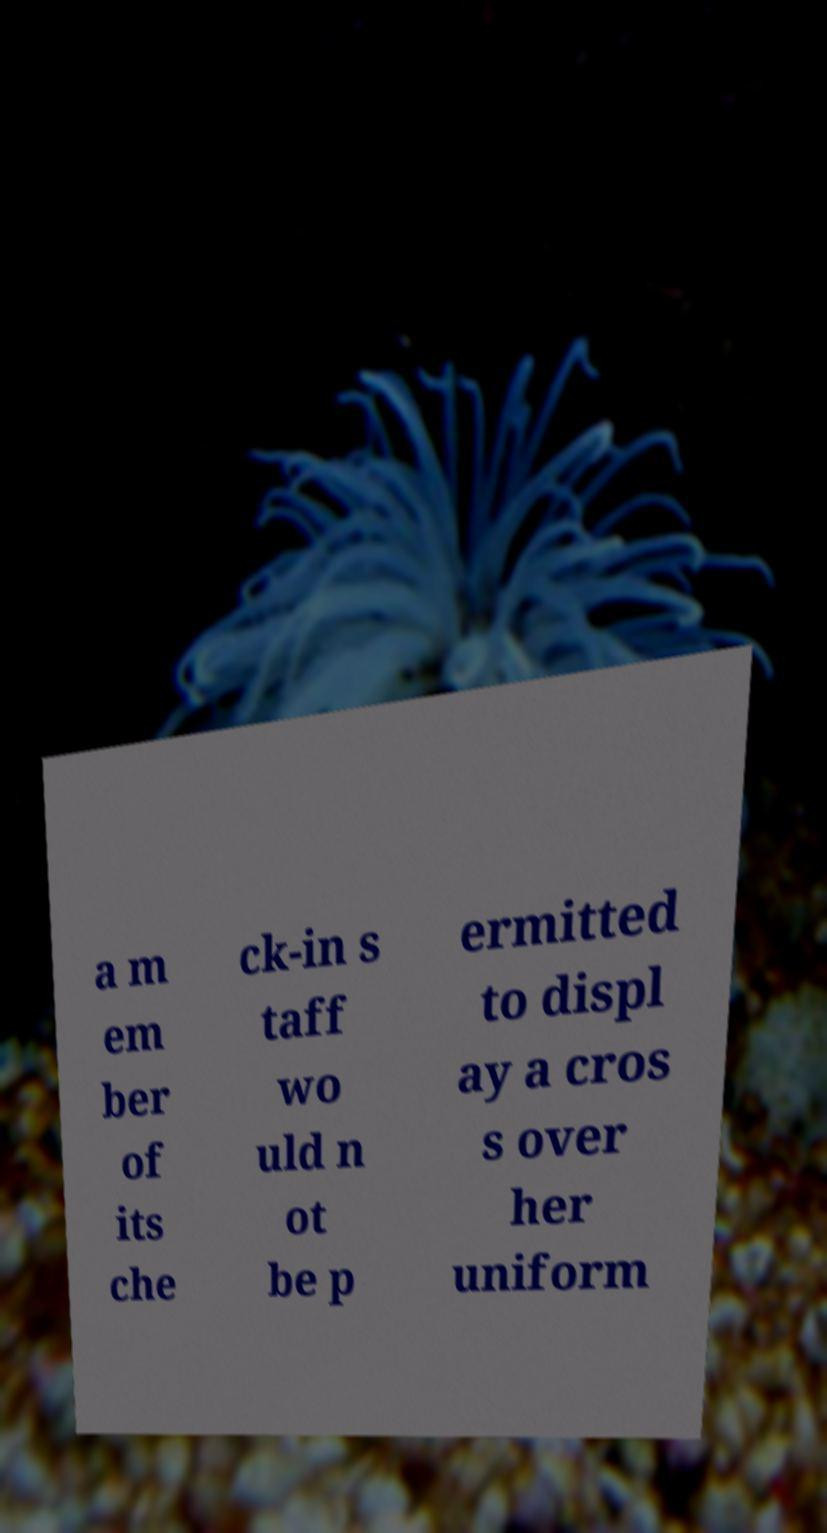For documentation purposes, I need the text within this image transcribed. Could you provide that? a m em ber of its che ck-in s taff wo uld n ot be p ermitted to displ ay a cros s over her uniform 